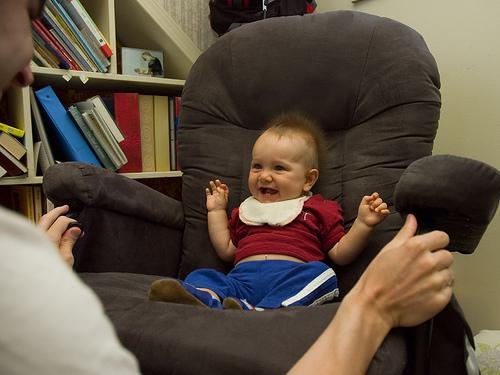What is the mood in the image? The mood in the image is joyful and playful. The laughing baby, open-handed gesture, and casual setting with books in the background suggest a relaxed and happy domestic scene. 